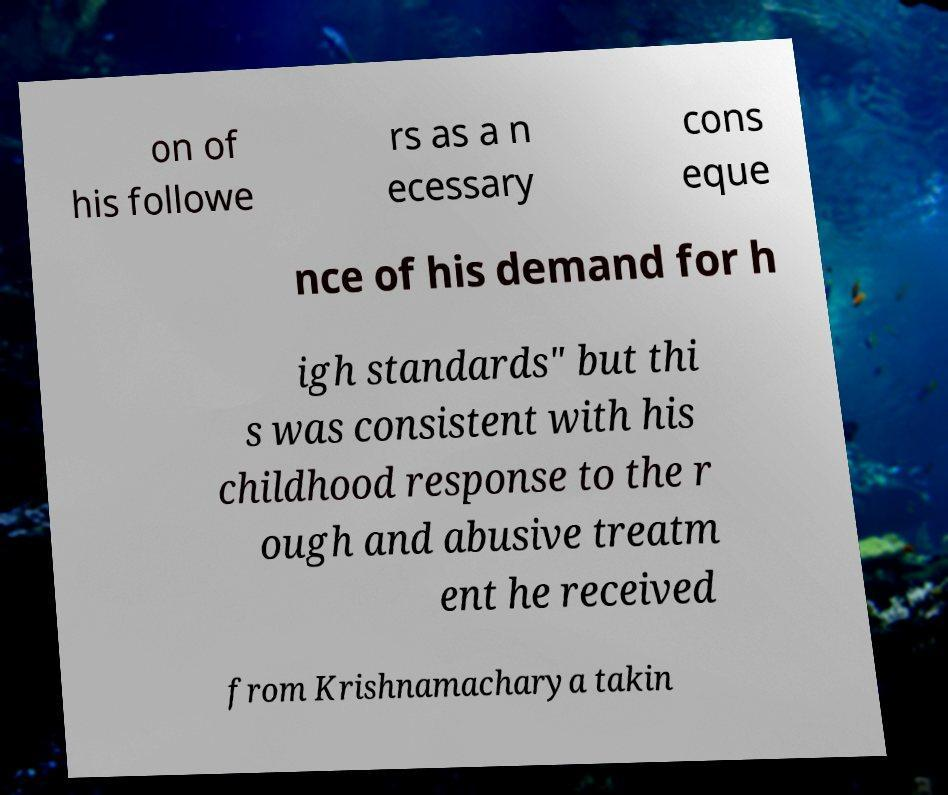Could you extract and type out the text from this image? on of his followe rs as a n ecessary cons eque nce of his demand for h igh standards" but thi s was consistent with his childhood response to the r ough and abusive treatm ent he received from Krishnamacharya takin 